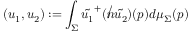Convert formula to latex. <formula><loc_0><loc_0><loc_500><loc_500>( u _ { 1 } , u _ { 2 } ) \colon = \int _ { \Sigma } \tilde { u _ { 1 } } ^ { + } ( { \not n } \tilde { u _ { 2 } } ) ( p ) d \mu _ { \Sigma } ( p )</formula> 